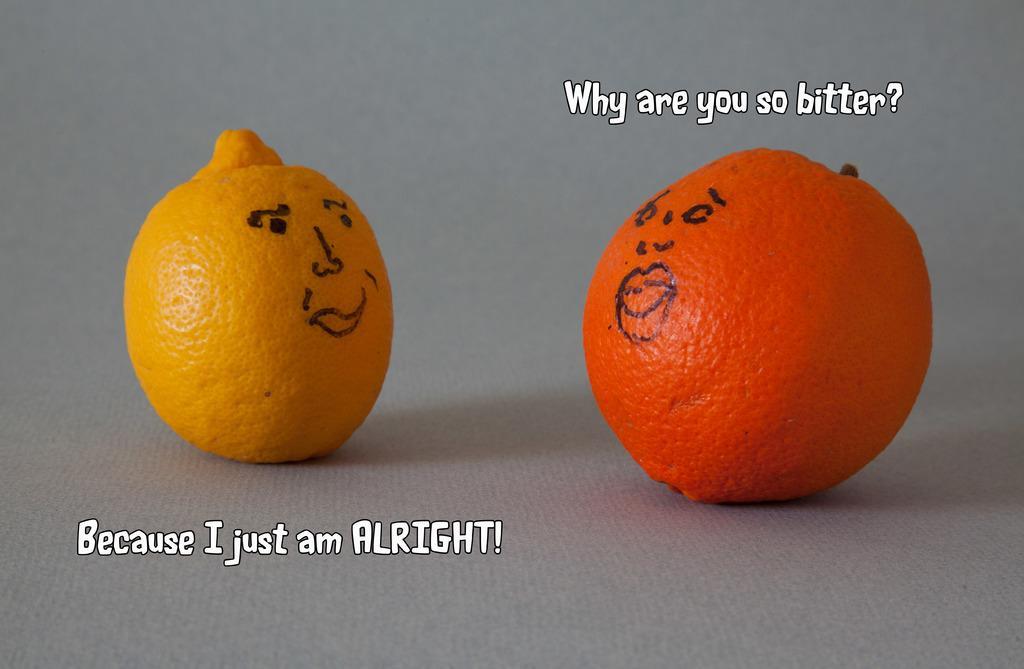In one or two sentences, can you explain what this image depicts? In this picture we can see two oranges on a platform, where we can see some text. 